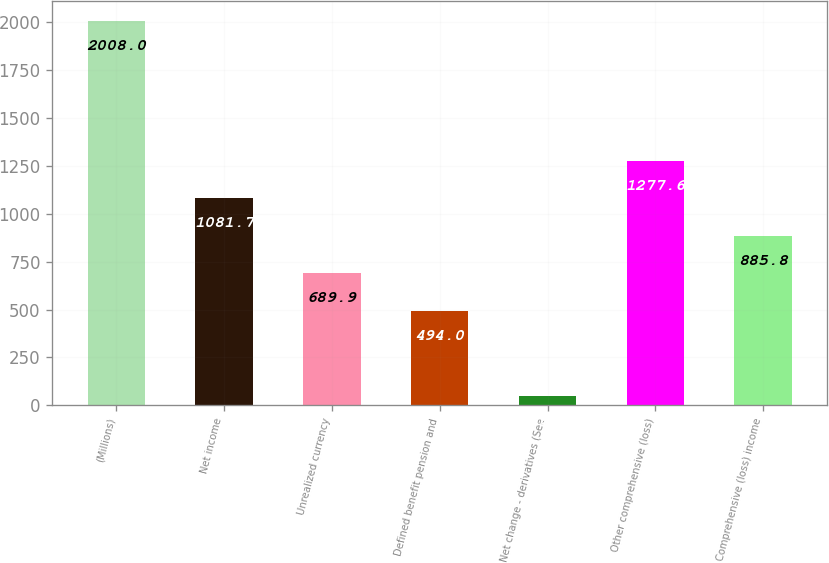Convert chart. <chart><loc_0><loc_0><loc_500><loc_500><bar_chart><fcel>(Millions)<fcel>Net income<fcel>Unrealized currency<fcel>Defined benefit pension and<fcel>Net change - derivatives (See<fcel>Other comprehensive (loss)<fcel>Comprehensive (loss) income<nl><fcel>2008<fcel>1081.7<fcel>689.9<fcel>494<fcel>49<fcel>1277.6<fcel>885.8<nl></chart> 